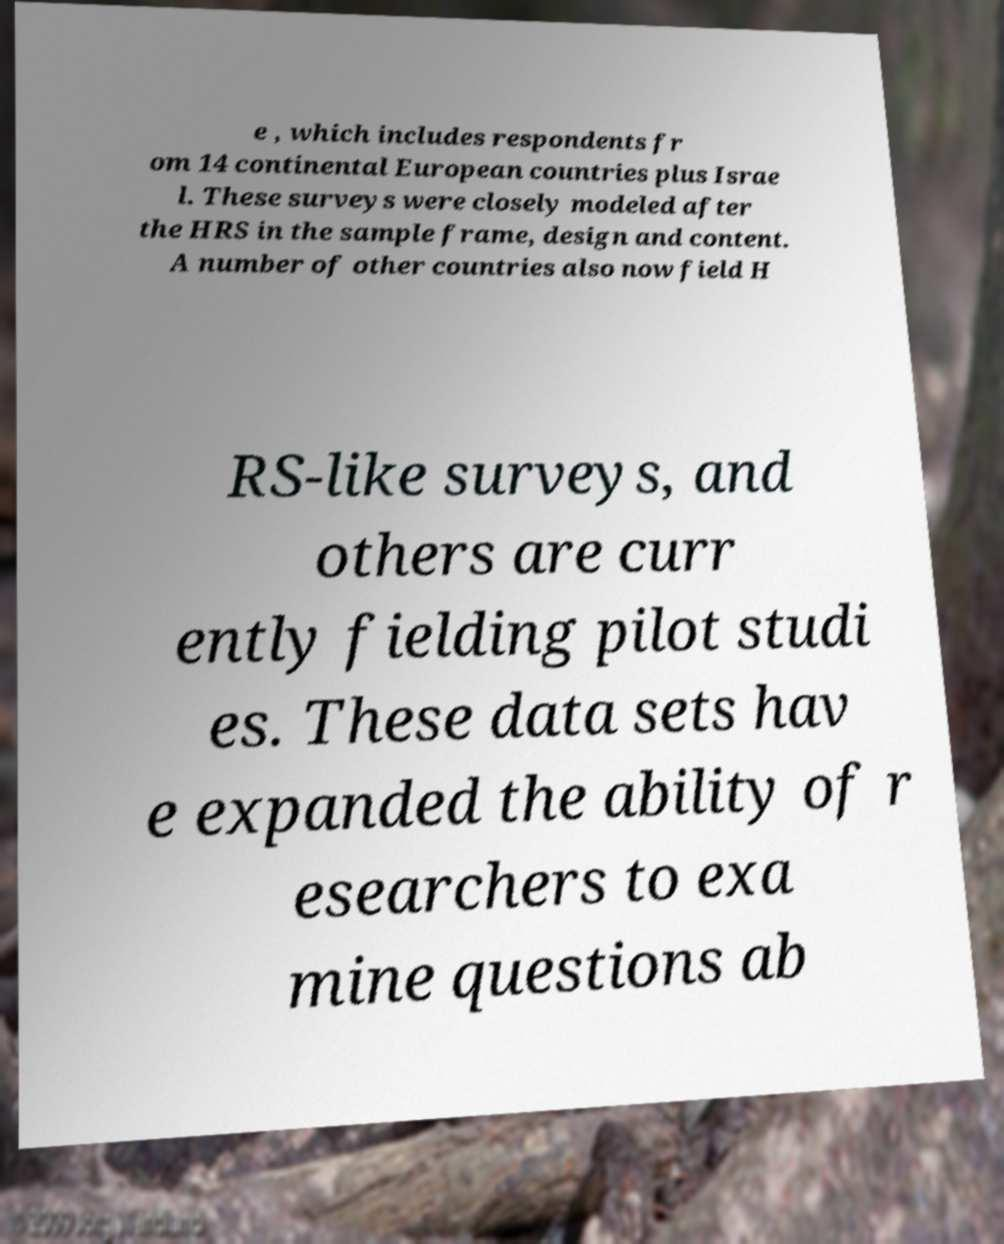For documentation purposes, I need the text within this image transcribed. Could you provide that? e , which includes respondents fr om 14 continental European countries plus Israe l. These surveys were closely modeled after the HRS in the sample frame, design and content. A number of other countries also now field H RS-like surveys, and others are curr ently fielding pilot studi es. These data sets hav e expanded the ability of r esearchers to exa mine questions ab 